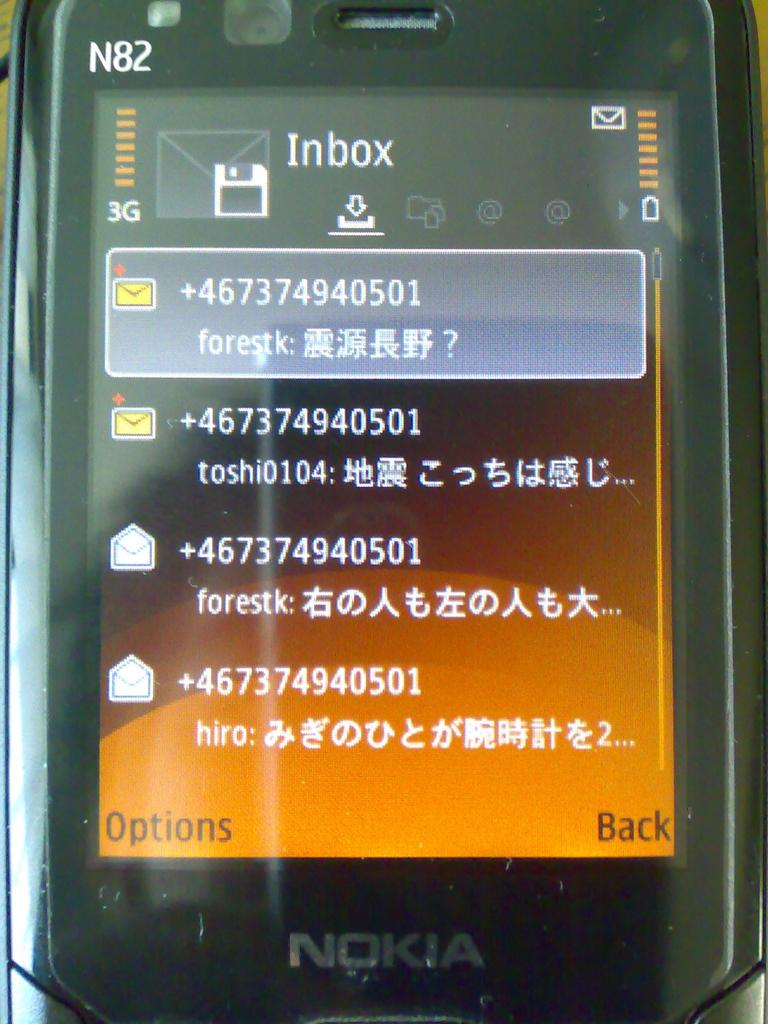<image>
Provide a brief description of the given image. A Nokia phone screen displays the phones inbox. 